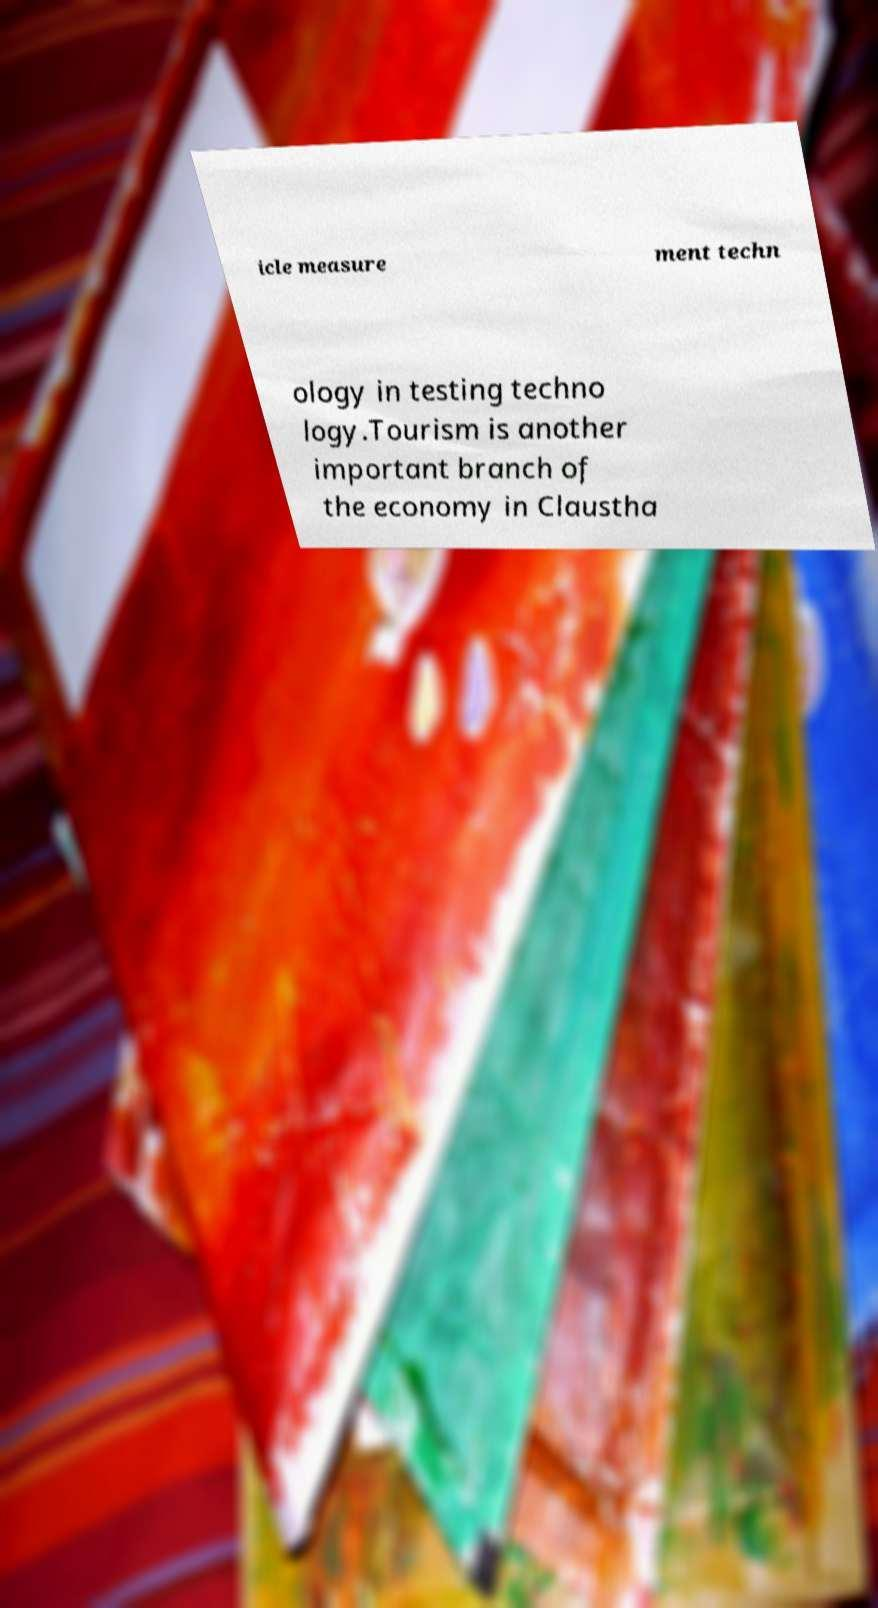Can you accurately transcribe the text from the provided image for me? icle measure ment techn ology in testing techno logy.Tourism is another important branch of the economy in Claustha 